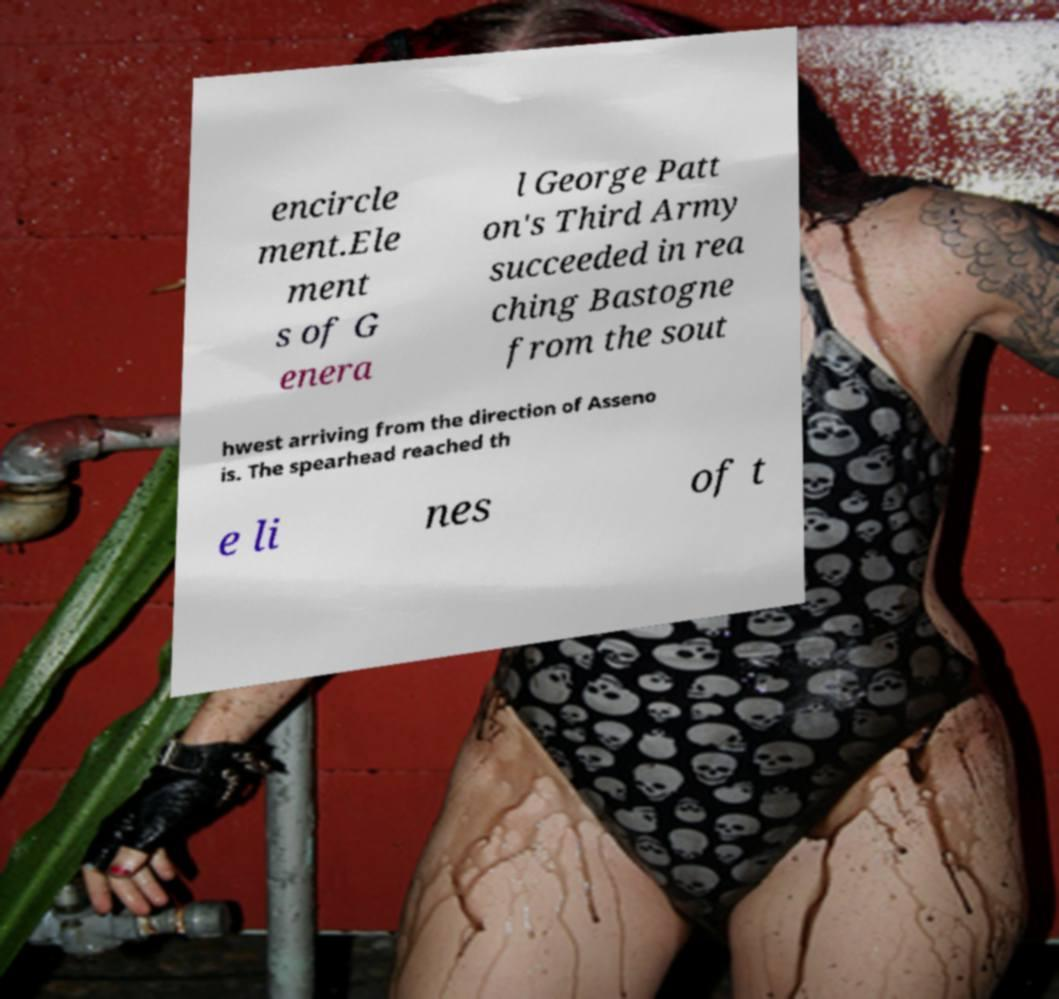Can you read and provide the text displayed in the image?This photo seems to have some interesting text. Can you extract and type it out for me? encircle ment.Ele ment s of G enera l George Patt on's Third Army succeeded in rea ching Bastogne from the sout hwest arriving from the direction of Asseno is. The spearhead reached th e li nes of t 